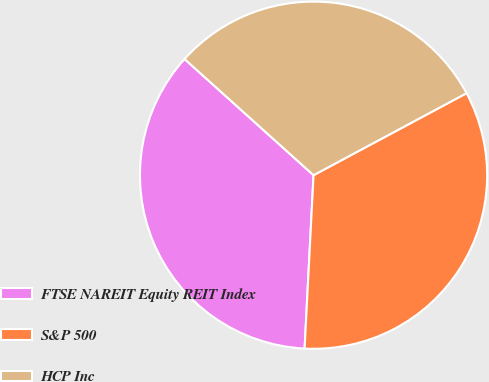<chart> <loc_0><loc_0><loc_500><loc_500><pie_chart><fcel>FTSE NAREIT Equity REIT Index<fcel>S&P 500<fcel>HCP Inc<nl><fcel>35.85%<fcel>33.65%<fcel>30.5%<nl></chart> 